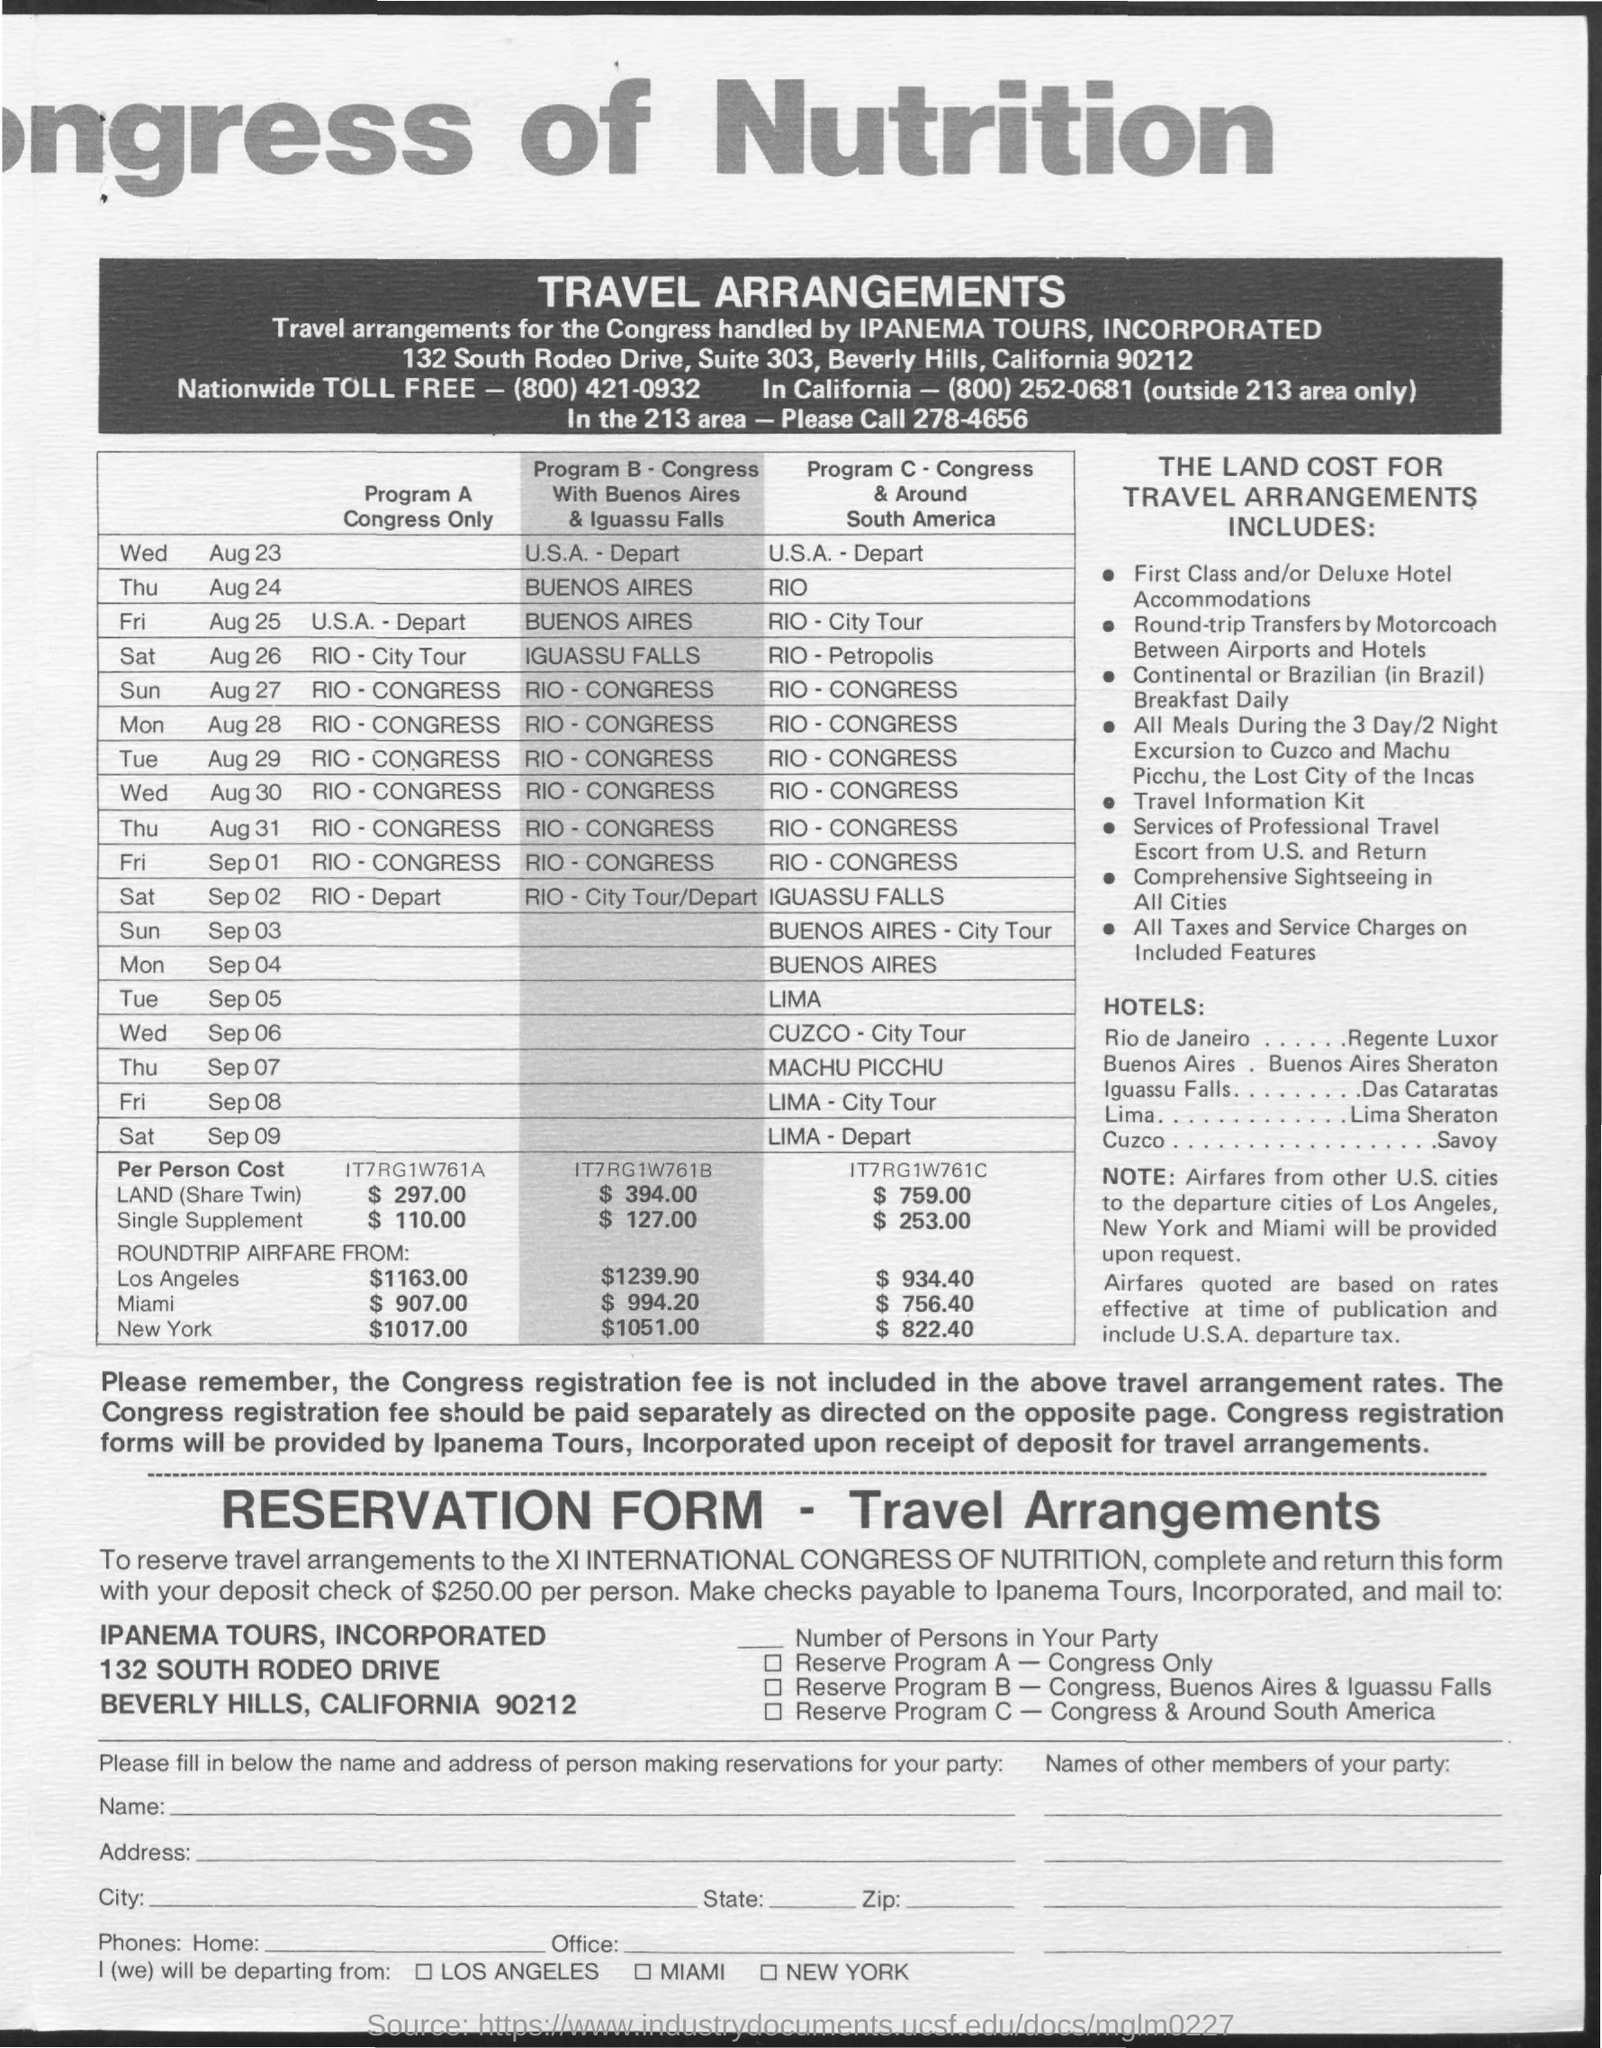Give some essential details in this illustration. The nationwide toll-free number is (800) 421-0932. 